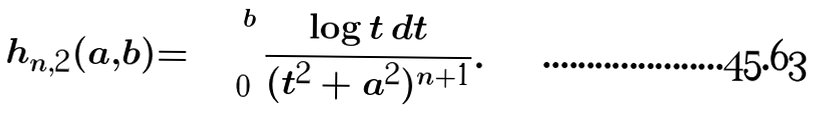<formula> <loc_0><loc_0><loc_500><loc_500>h _ { n , 2 } ( a , b ) = \int _ { 0 } ^ { b } \frac { \log t \, d t } { ( t ^ { 2 } + a ^ { 2 } ) ^ { n + 1 } } .</formula> 